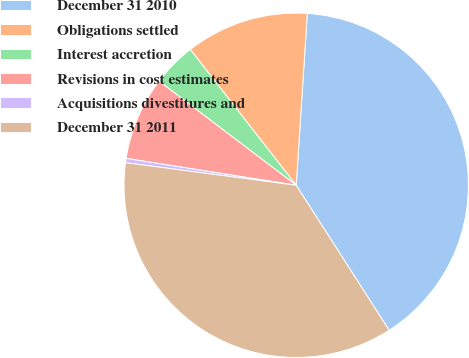Convert chart to OTSL. <chart><loc_0><loc_0><loc_500><loc_500><pie_chart><fcel>December 31 2010<fcel>Obligations settled<fcel>Interest accretion<fcel>Revisions in cost estimates<fcel>Acquisitions divestitures and<fcel>December 31 2011<nl><fcel>39.9%<fcel>11.57%<fcel>4.12%<fcel>7.84%<fcel>0.4%<fcel>36.17%<nl></chart> 